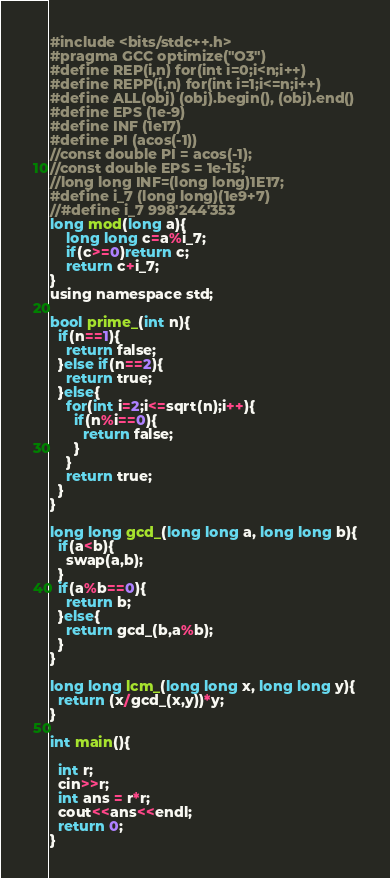<code> <loc_0><loc_0><loc_500><loc_500><_C_>#include <bits/stdc++.h>
#pragma GCC optimize("O3")
#define REP(i,n) for(int i=0;i<n;i++)
#define REPP(i,n) for(int i=1;i<=n;i++)
#define ALL(obj) (obj).begin(), (obj).end()
#define EPS (1e-9)
#define INF (1e17)
#define PI (acos(-1))
//const double PI = acos(-1);
//const double EPS = 1e-15;
//long long INF=(long long)1E17;
#define i_7 (long long)(1e9+7)
//#define i_7 998'244'353
long mod(long a){
    long long c=a%i_7;
    if(c>=0)return c;
    return c+i_7;
}
using namespace std;

bool prime_(int n){
  if(n==1){
    return false;
  }else if(n==2){
    return true;
  }else{
    for(int i=2;i<=sqrt(n);i++){
      if(n%i==0){
        return false;
      }
    }
    return true;
  }
}

long long gcd_(long long a, long long b){
  if(a<b){
    swap(a,b);
  }
  if(a%b==0){
    return b;
  }else{
    return gcd_(b,a%b);
  }
}
 
long long lcm_(long long x, long long y){
  return (x/gcd_(x,y))*y;
}

int main(){
  
  int r;
  cin>>r;
  int ans = r*r;
  cout<<ans<<endl;
  return 0; 
}</code> 